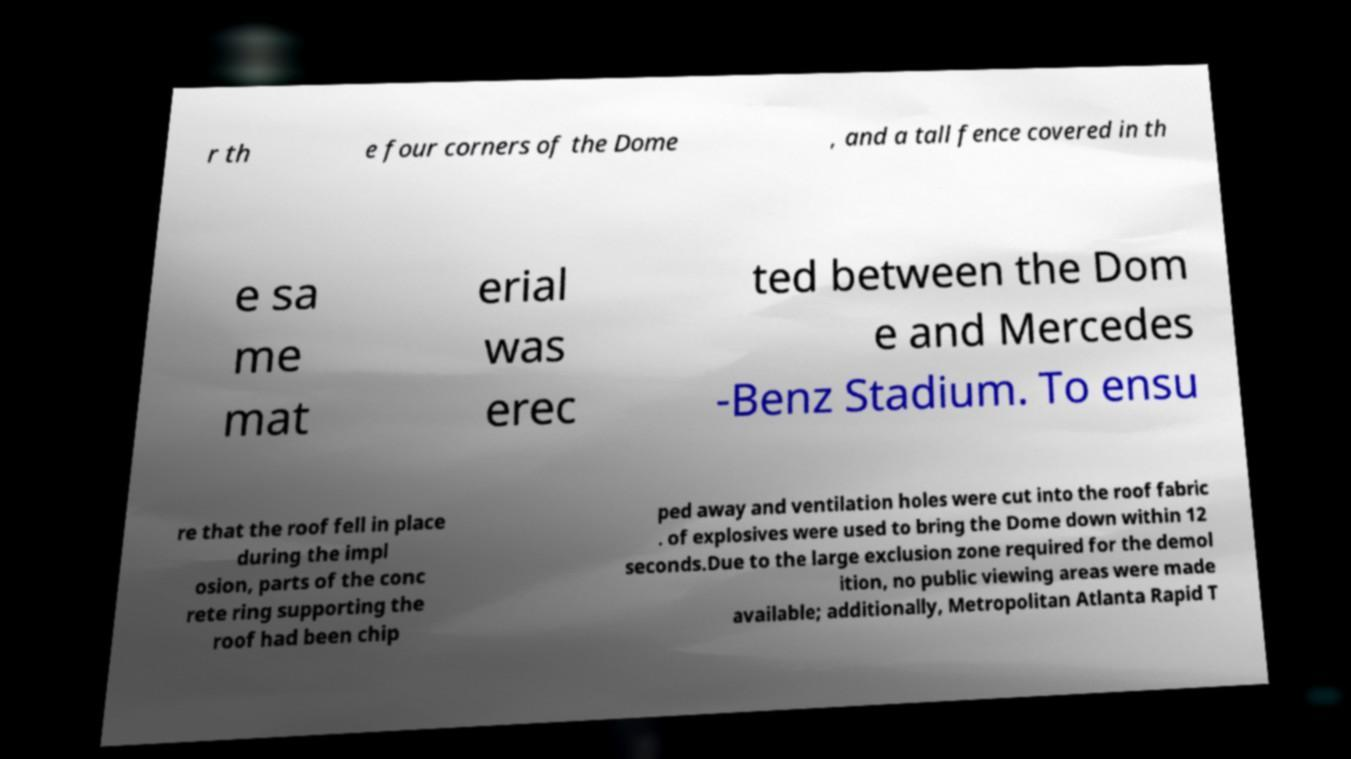There's text embedded in this image that I need extracted. Can you transcribe it verbatim? r th e four corners of the Dome , and a tall fence covered in th e sa me mat erial was erec ted between the Dom e and Mercedes -Benz Stadium. To ensu re that the roof fell in place during the impl osion, parts of the conc rete ring supporting the roof had been chip ped away and ventilation holes were cut into the roof fabric . of explosives were used to bring the Dome down within 12 seconds.Due to the large exclusion zone required for the demol ition, no public viewing areas were made available; additionally, Metropolitan Atlanta Rapid T 